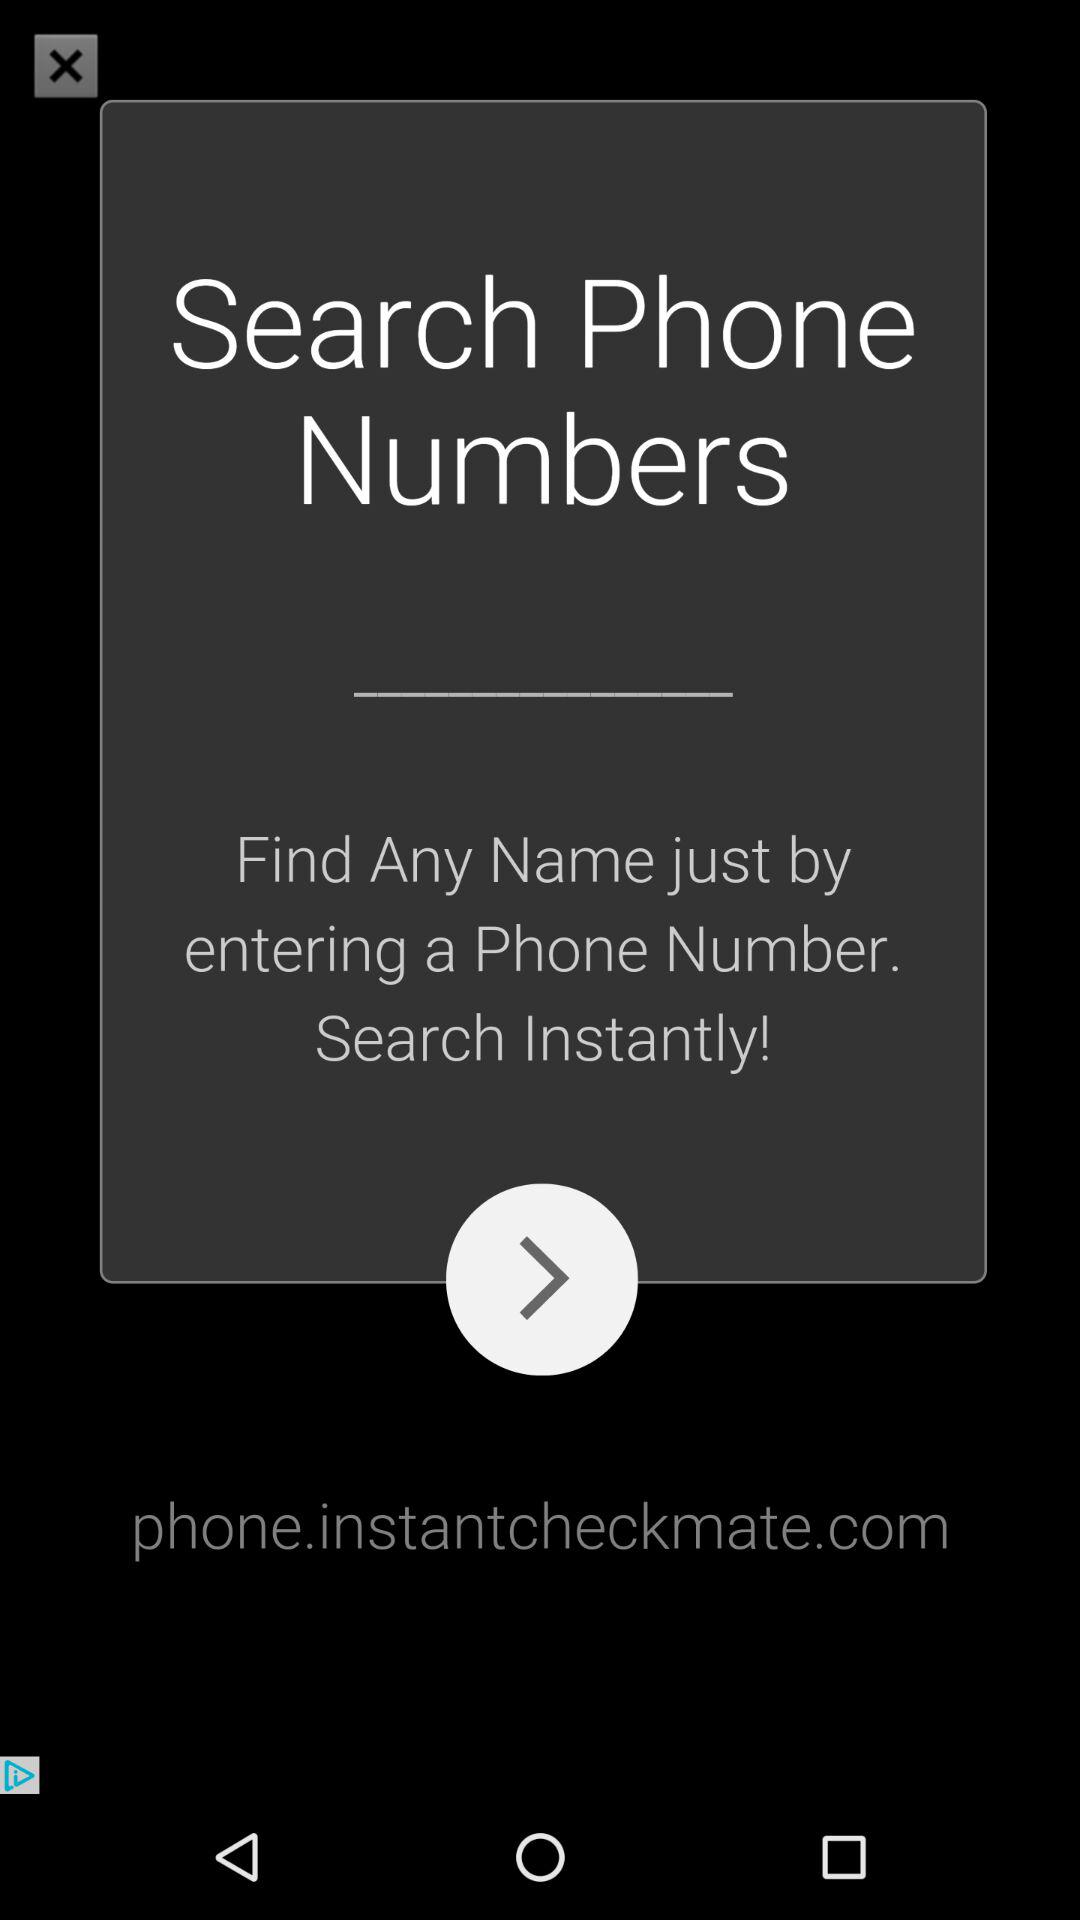How can we find any name? You can find any name by entering a phone number. 